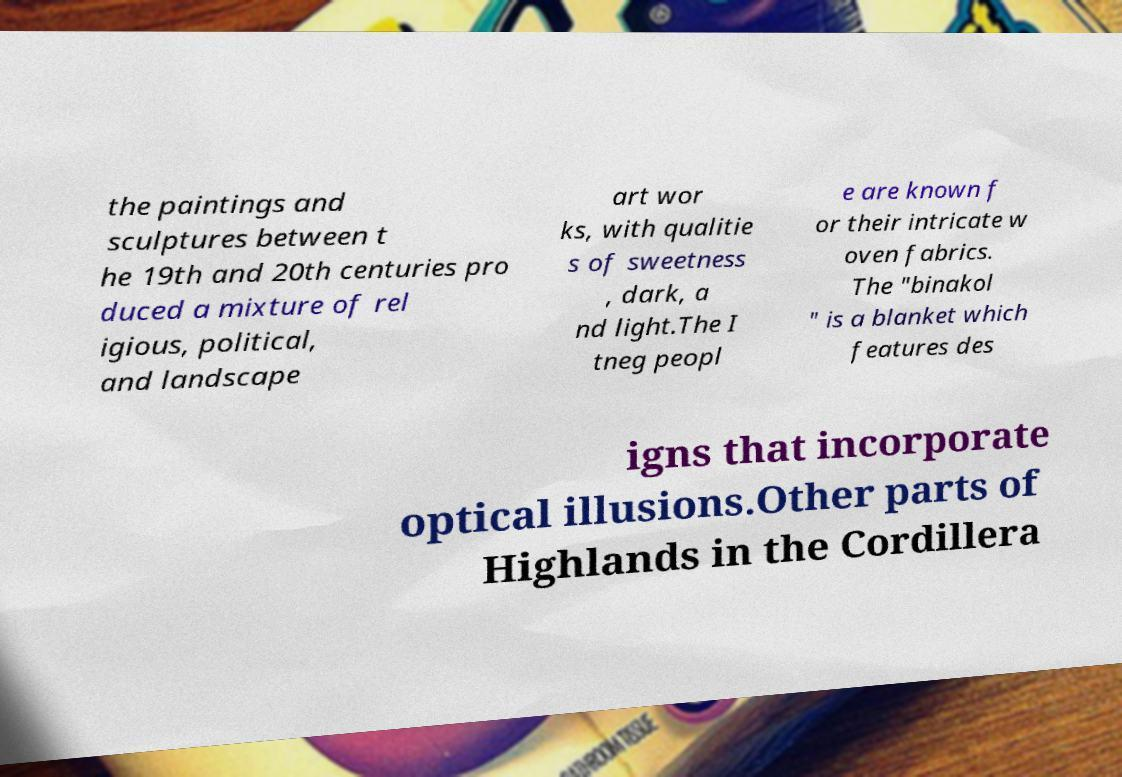There's text embedded in this image that I need extracted. Can you transcribe it verbatim? the paintings and sculptures between t he 19th and 20th centuries pro duced a mixture of rel igious, political, and landscape art wor ks, with qualitie s of sweetness , dark, a nd light.The I tneg peopl e are known f or their intricate w oven fabrics. The "binakol " is a blanket which features des igns that incorporate optical illusions.Other parts of Highlands in the Cordillera 